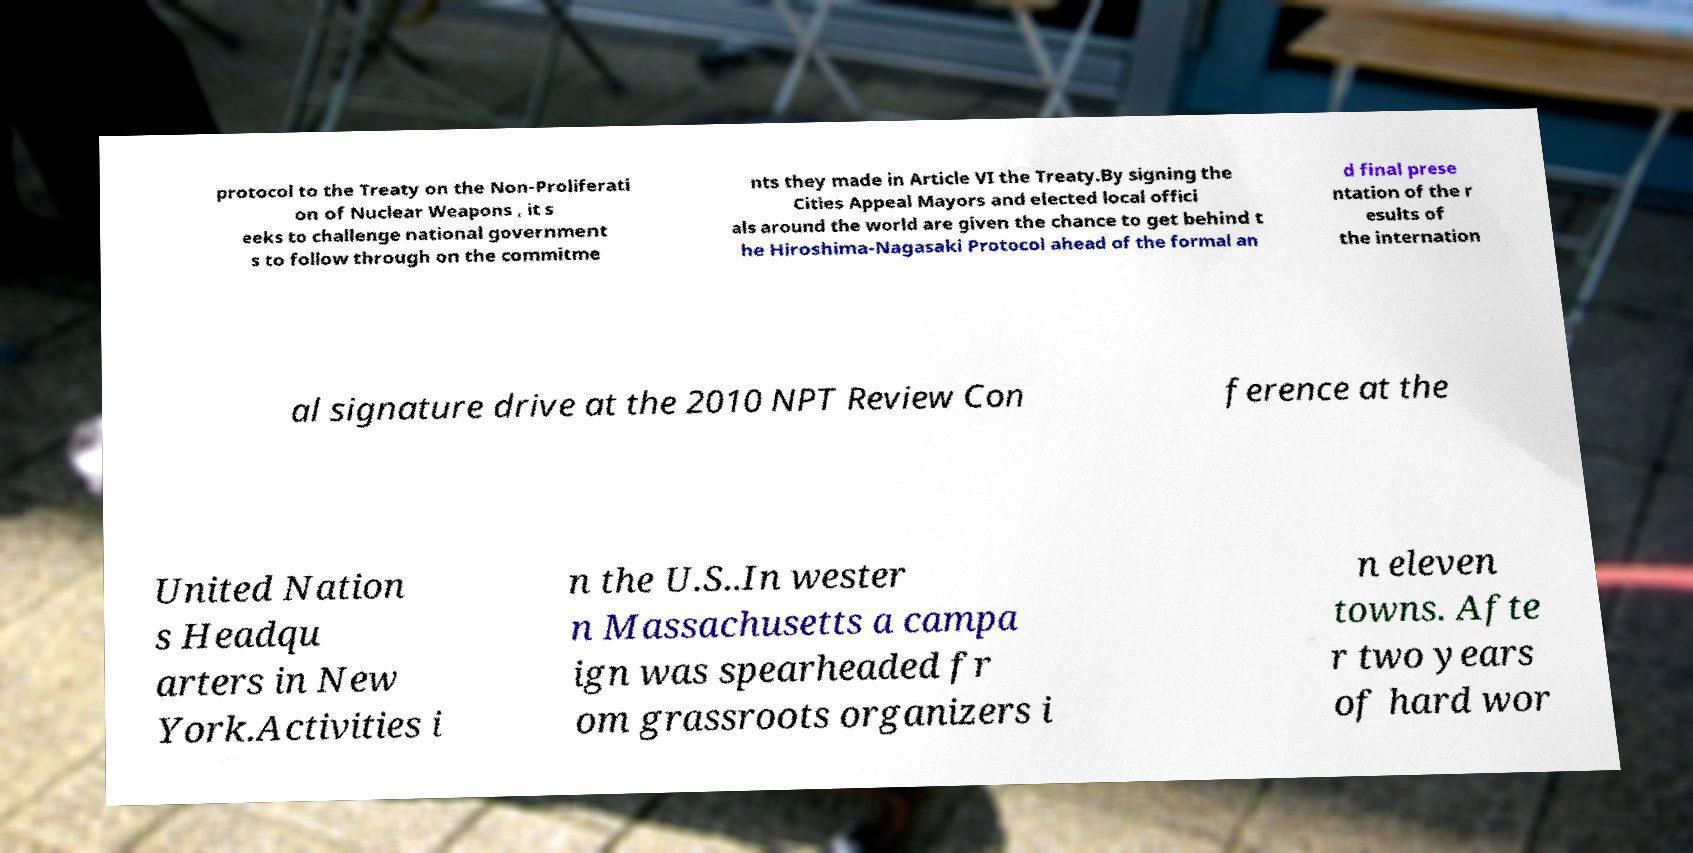Could you extract and type out the text from this image? protocol to the Treaty on the Non-Proliferati on of Nuclear Weapons , it s eeks to challenge national government s to follow through on the commitme nts they made in Article VI the Treaty.By signing the Cities Appeal Mayors and elected local offici als around the world are given the chance to get behind t he Hiroshima-Nagasaki Protocol ahead of the formal an d final prese ntation of the r esults of the internation al signature drive at the 2010 NPT Review Con ference at the United Nation s Headqu arters in New York.Activities i n the U.S..In wester n Massachusetts a campa ign was spearheaded fr om grassroots organizers i n eleven towns. Afte r two years of hard wor 